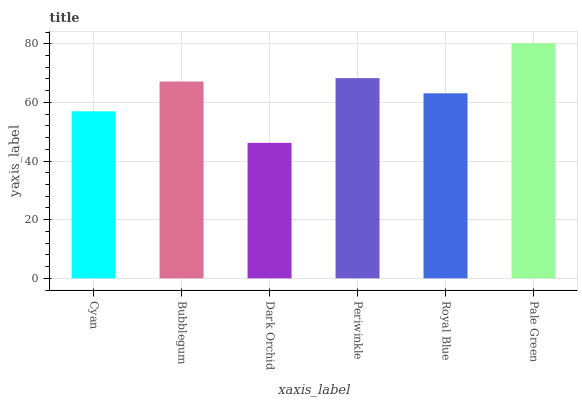Is Dark Orchid the minimum?
Answer yes or no. Yes. Is Pale Green the maximum?
Answer yes or no. Yes. Is Bubblegum the minimum?
Answer yes or no. No. Is Bubblegum the maximum?
Answer yes or no. No. Is Bubblegum greater than Cyan?
Answer yes or no. Yes. Is Cyan less than Bubblegum?
Answer yes or no. Yes. Is Cyan greater than Bubblegum?
Answer yes or no. No. Is Bubblegum less than Cyan?
Answer yes or no. No. Is Bubblegum the high median?
Answer yes or no. Yes. Is Royal Blue the low median?
Answer yes or no. Yes. Is Dark Orchid the high median?
Answer yes or no. No. Is Dark Orchid the low median?
Answer yes or no. No. 